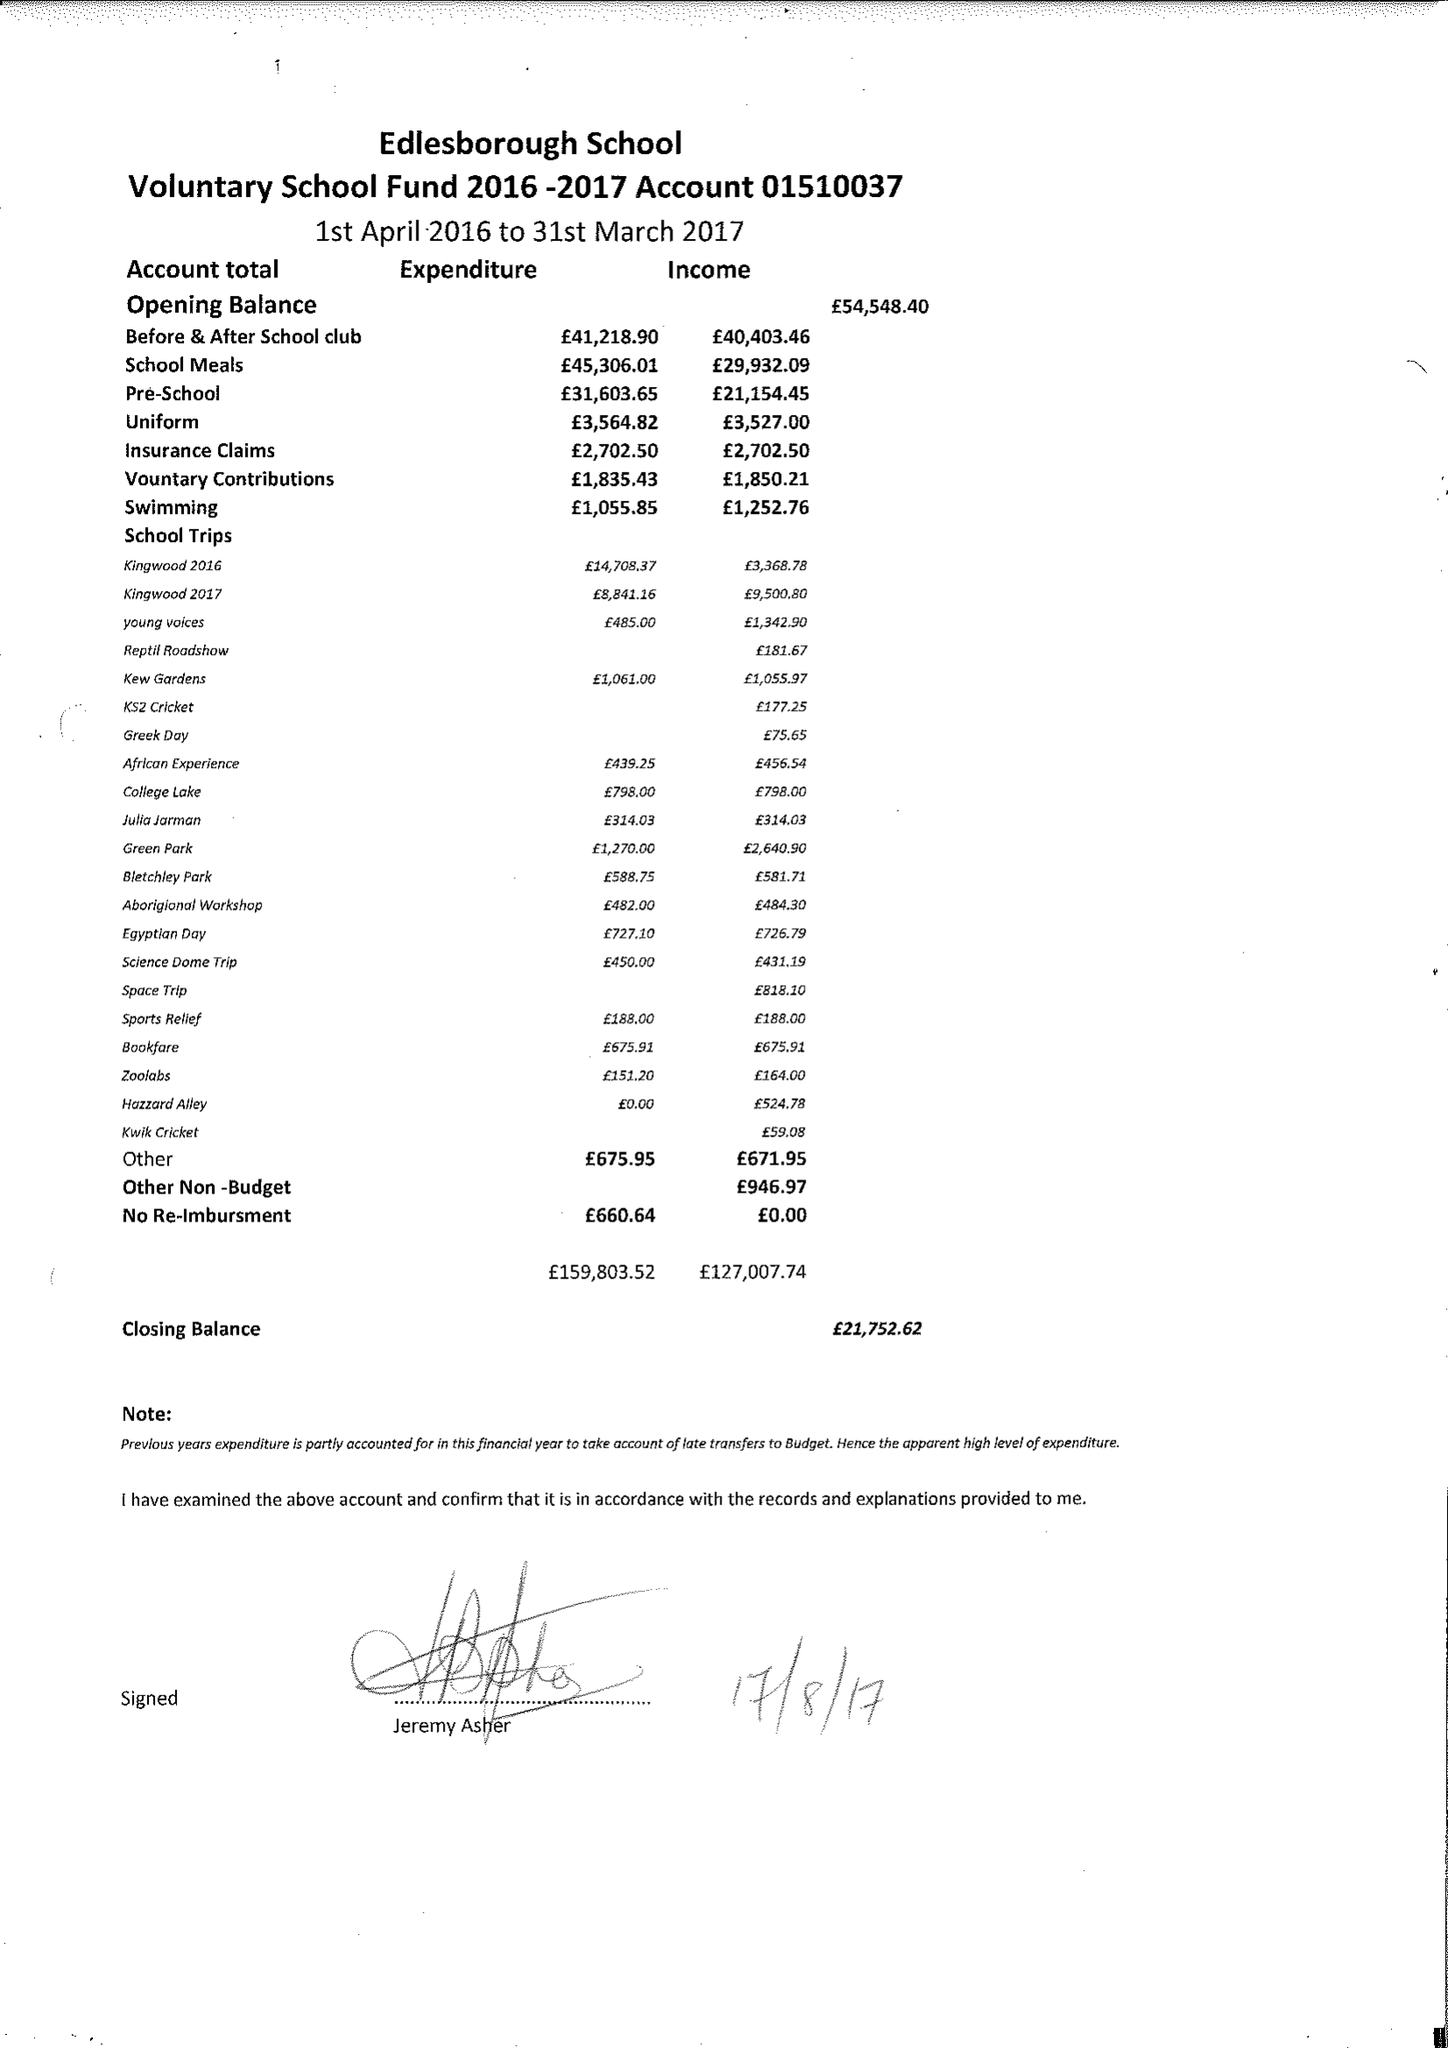What is the value for the address__post_town?
Answer the question using a single word or phrase. DUNSTABLE 